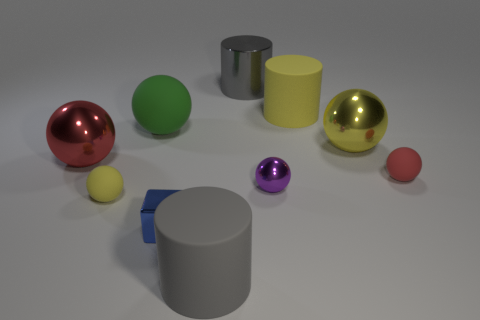There is a green rubber thing that is the same size as the gray matte object; what shape is it? sphere 